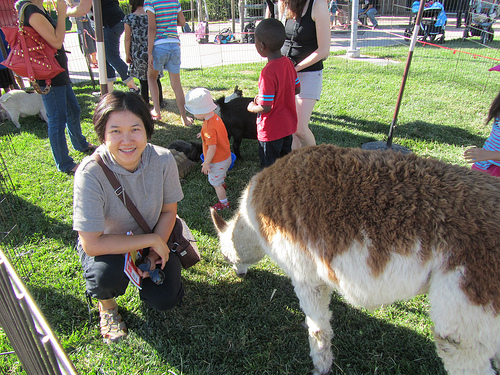Please provide a short description for this region: [0.03, 0.13, 0.17, 0.47]. The region captures a woman who appears to be talking, adding a sense of interaction and liveliness to the scene. 